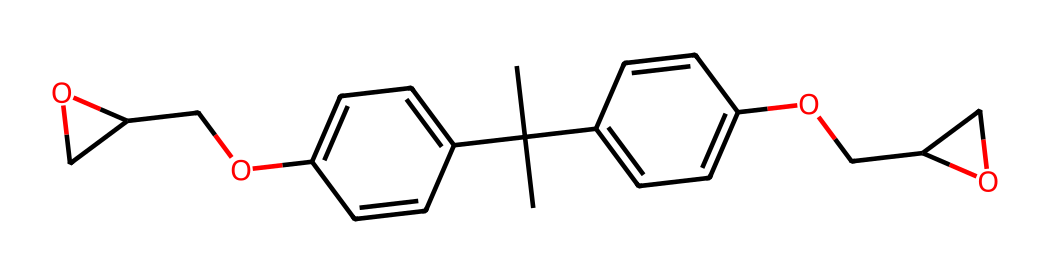What is the main functional group present in this polymer? The polymer contains ether linkages as indicated by the presence of -O- in the structure. Additionally, phenolic groups can be observed, supporting its epoxy nature.
Answer: ether How many carbon atoms are present in this chemical structure? By counting the 'C's in the SMILES notation, there are a total of 24 carbon atoms in the structure.
Answer: 24 What type of polymer is this compound primarily classified as? This compound is primarily classified as an epoxy resin due to its epoxide functional groups and network-forming properties in cured states.
Answer: epoxy resin How many distinct rings are present in this chemical? There are two distinct aromatic rings visible in the structure, which contribute to the rigidity of the polymer.
Answer: 2 What type of cross-linking does this resin undergo upon curing? Upon curing, the polymer exhibits thermosetting characteristics, involving thermoset cross-linking reactions that enhance its mechanical properties.
Answer: thermoset What is the significance of the -O- groups in this polymer? The -O- (ether) groups enhance the adhesive properties and thermal stability of the resin, which are critical for applications like circuit boards.
Answer: adhesive properties 